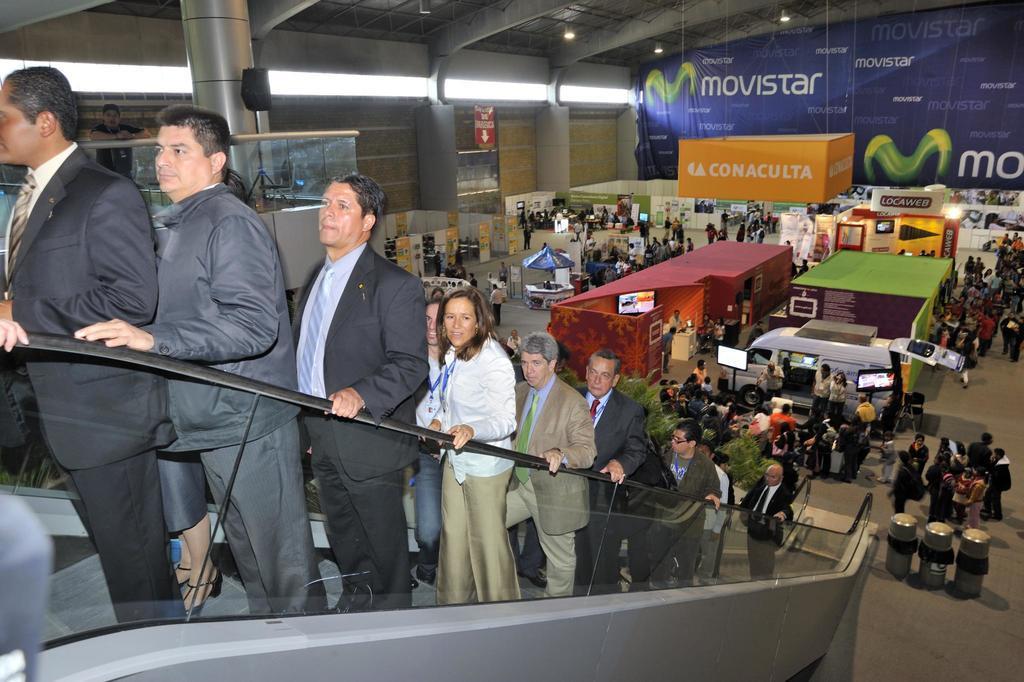Can you describe this image briefly? In this picture we can see group of people in the store and we can find few people on the escalator, in the background we can find few screens, lights, hoardings, metal rods and a speaker. 